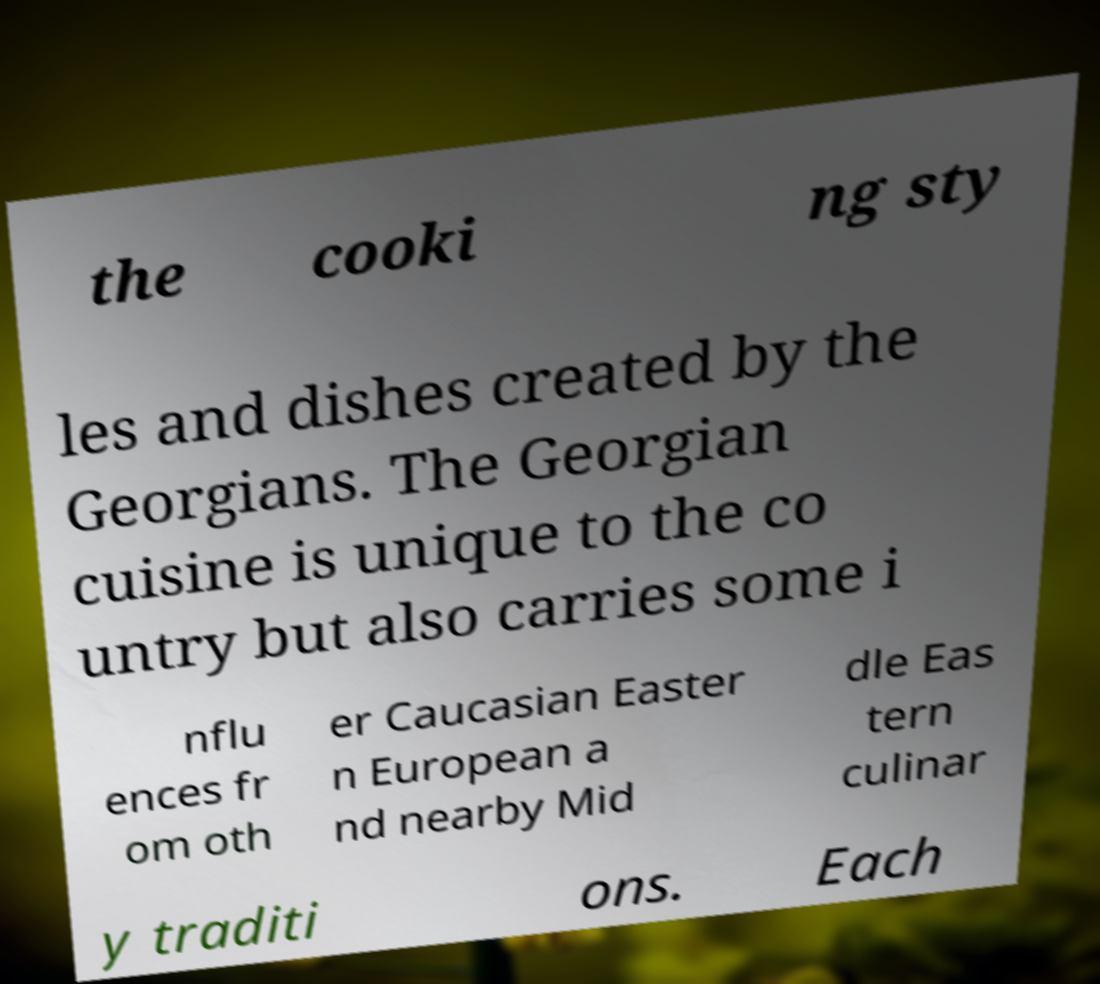Can you accurately transcribe the text from the provided image for me? the cooki ng sty les and dishes created by the Georgians. The Georgian cuisine is unique to the co untry but also carries some i nflu ences fr om oth er Caucasian Easter n European a nd nearby Mid dle Eas tern culinar y traditi ons. Each 